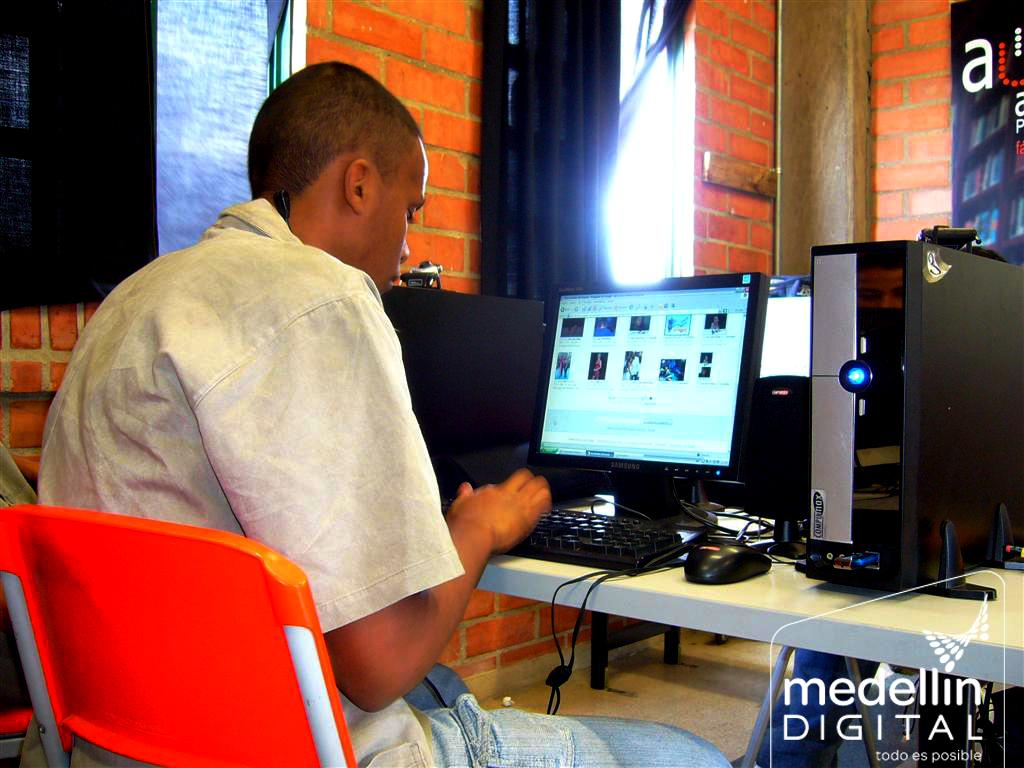Provide a one-sentence caption for the provided image. A computer user works on a PC in a visual from Medellin Digital. 